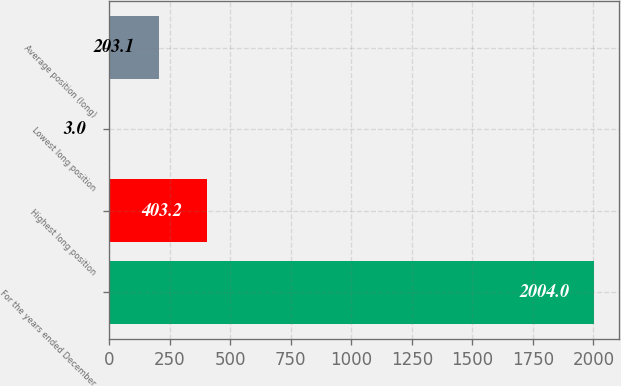Convert chart to OTSL. <chart><loc_0><loc_0><loc_500><loc_500><bar_chart><fcel>For the years ended December<fcel>Highest long position<fcel>Lowest long position<fcel>Average position (long)<nl><fcel>2004<fcel>403.2<fcel>3<fcel>203.1<nl></chart> 